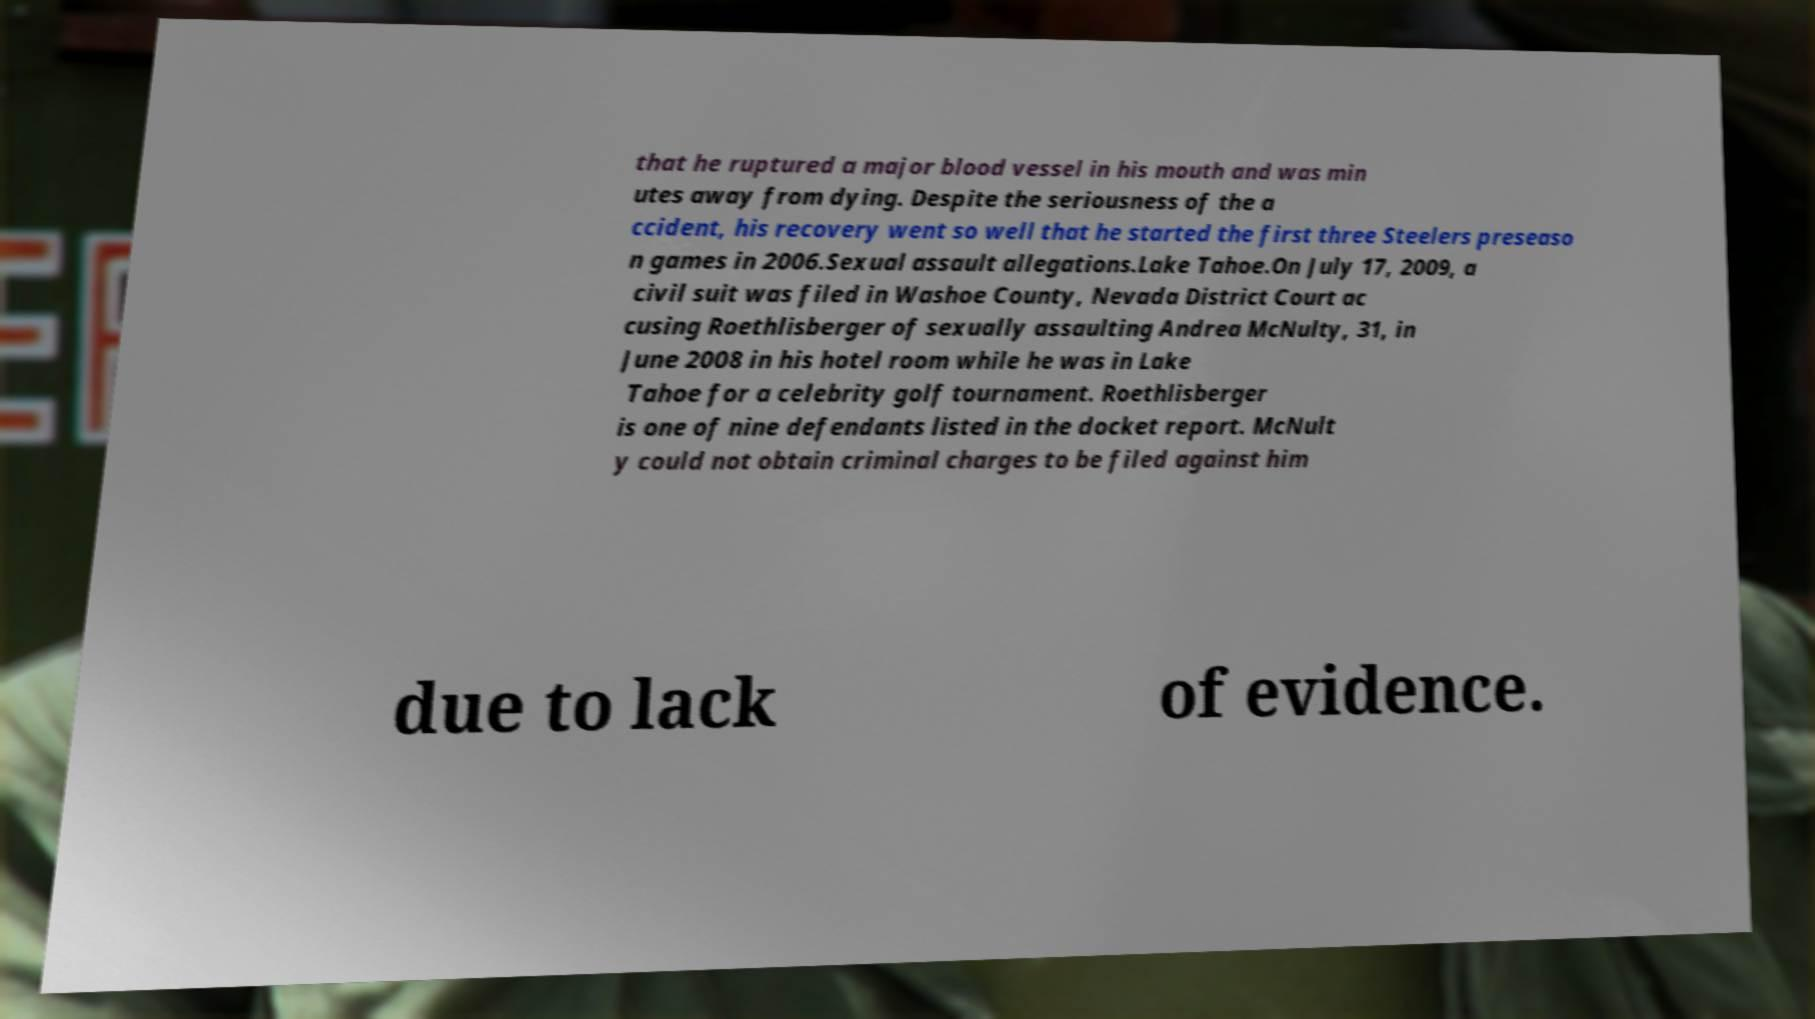Could you extract and type out the text from this image? that he ruptured a major blood vessel in his mouth and was min utes away from dying. Despite the seriousness of the a ccident, his recovery went so well that he started the first three Steelers preseaso n games in 2006.Sexual assault allegations.Lake Tahoe.On July 17, 2009, a civil suit was filed in Washoe County, Nevada District Court ac cusing Roethlisberger of sexually assaulting Andrea McNulty, 31, in June 2008 in his hotel room while he was in Lake Tahoe for a celebrity golf tournament. Roethlisberger is one of nine defendants listed in the docket report. McNult y could not obtain criminal charges to be filed against him due to lack of evidence. 